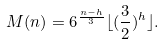Convert formula to latex. <formula><loc_0><loc_0><loc_500><loc_500>M ( n ) = 6 ^ { \frac { n - h } { 3 } } \lfloor ( \frac { 3 } { 2 } ) ^ { h } \rfloor .</formula> 